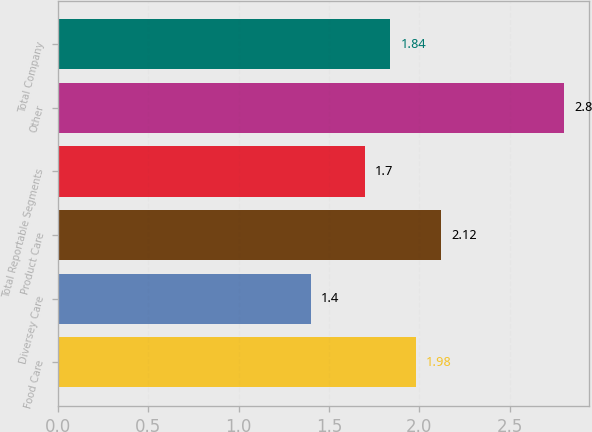Convert chart to OTSL. <chart><loc_0><loc_0><loc_500><loc_500><bar_chart><fcel>Food Care<fcel>Diversey Care<fcel>Product Care<fcel>Total Reportable Segments<fcel>Other<fcel>Total Company<nl><fcel>1.98<fcel>1.4<fcel>2.12<fcel>1.7<fcel>2.8<fcel>1.84<nl></chart> 